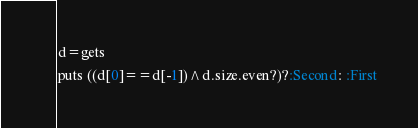<code> <loc_0><loc_0><loc_500><loc_500><_Ruby_>d=gets
puts ((d[0]==d[-1])^d.size.even?)?:Second: :First
</code> 